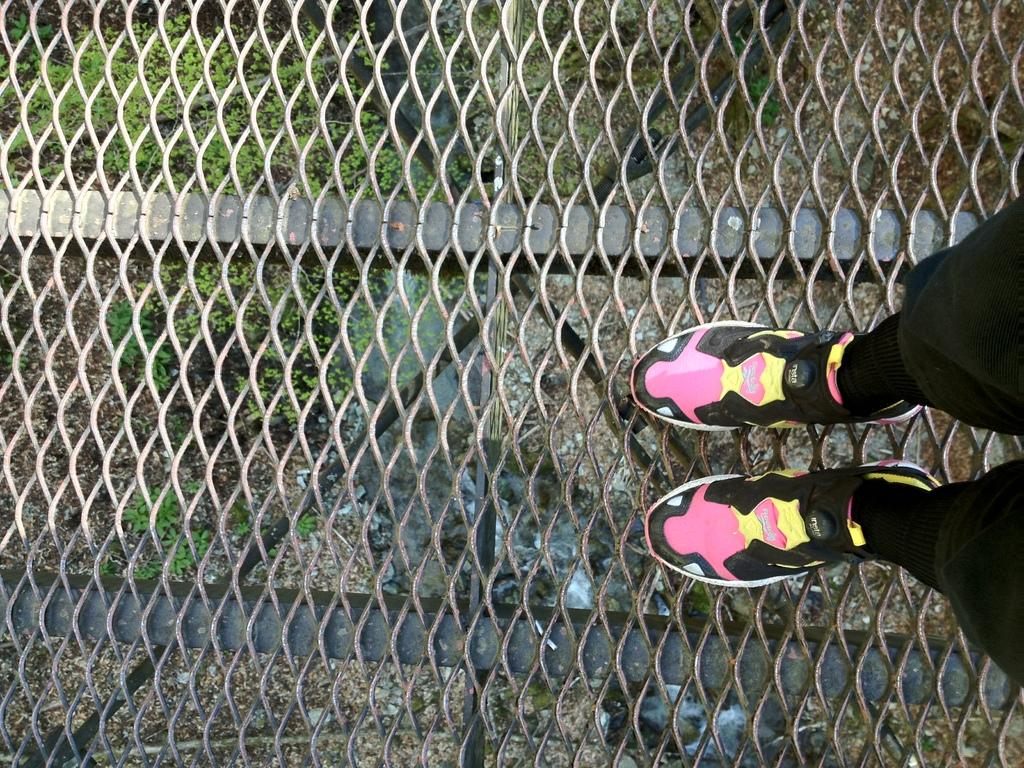What type of barrier can be seen in the image? There is a fence in the image. What part of a person can be seen in the image? Human legs are visible in the image. What type of vegetation is present in the image? There is grass in the image. What type of furniture is present in the image? There is no furniture present in the image; it features a fence, human legs, and grass. What plot of land is visible in the image? The image does not show a specific plot of land; it only shows a fence, human legs, and grass. 